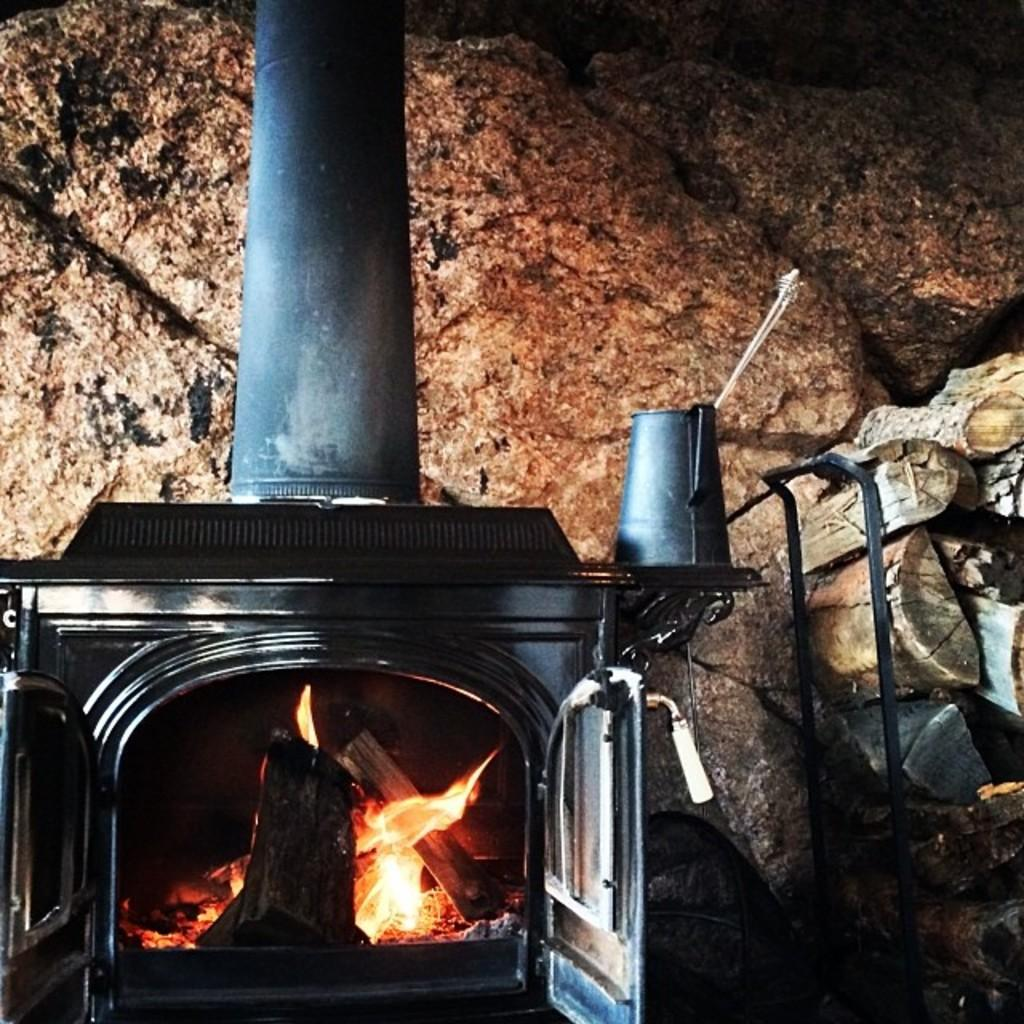What type of structure is present in the image? There is a fireplace in the image. What is connected to the fireplace? There is a fire outlet connected to the fireplace. What is inside the mug in the image? There are arrows in a mug in the image. What type of material is on the left side of the image? There are wooden bark pieces on the left side of the image. What can be seen in the background of the image? There are rocks visible in the background of the image. What type of loaf is being toasted in the fireplace? There is no loaf present in the image, and the fireplace is not being used for toasting anything. 